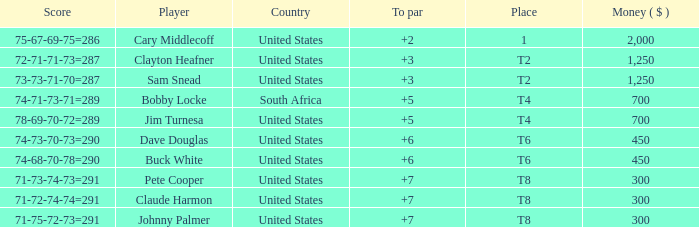What is Claude Harmon's Place? T8. 